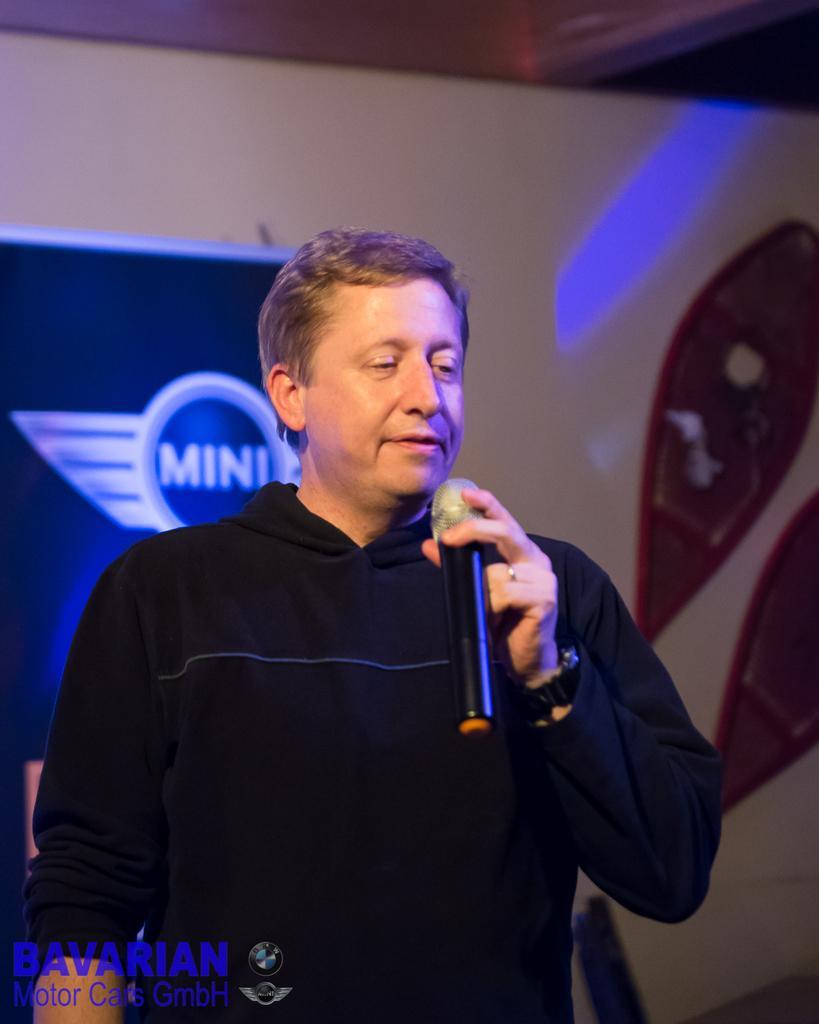Please provide a concise description of this image. This picture shows a man standing and holding a mic in his hands. In the background there is a poster and a wall. 